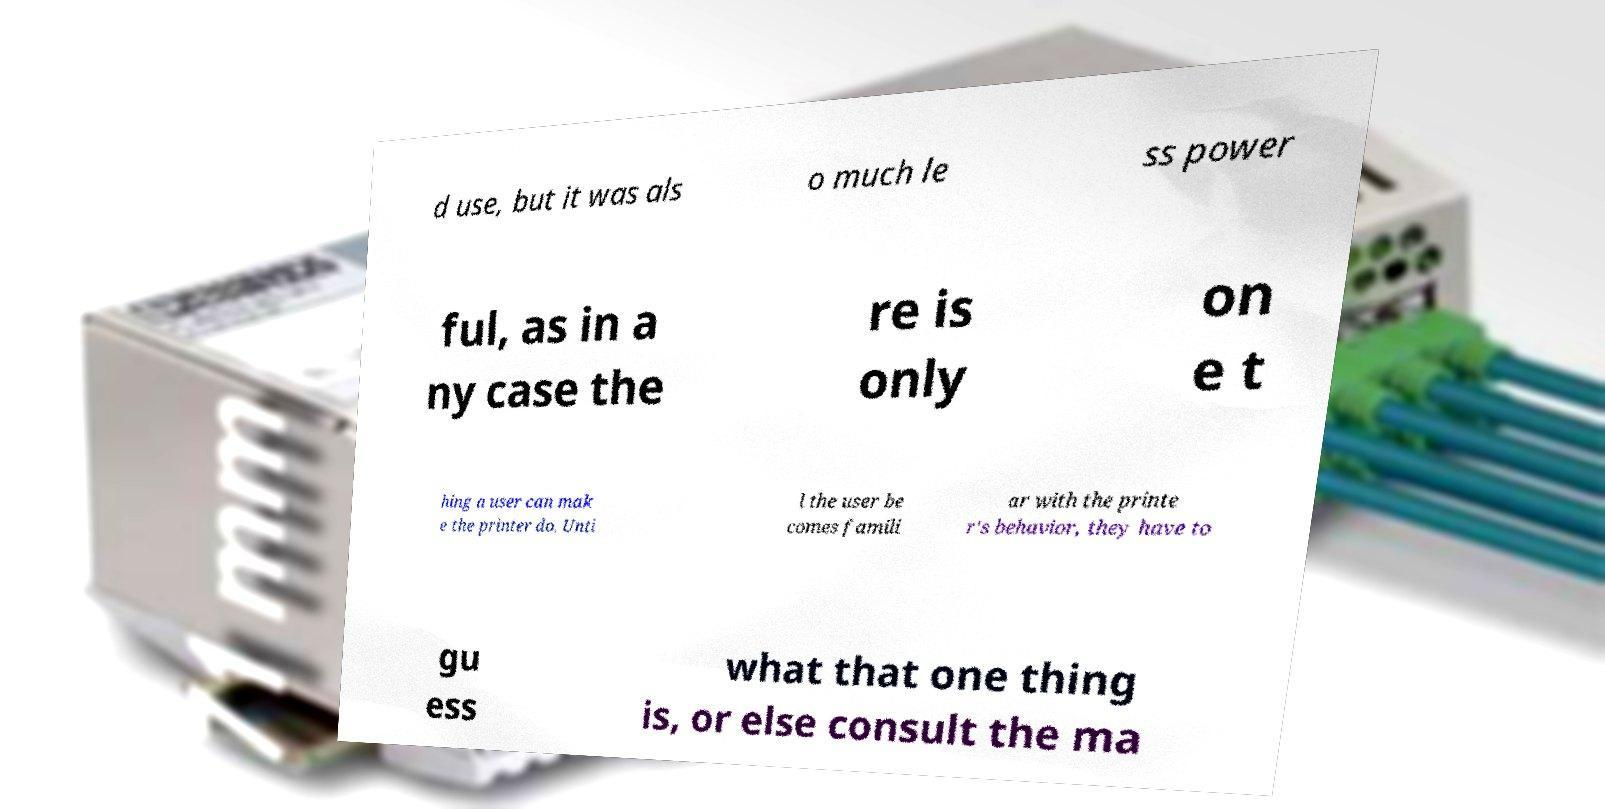Please identify and transcribe the text found in this image. d use, but it was als o much le ss power ful, as in a ny case the re is only on e t hing a user can mak e the printer do. Unti l the user be comes famili ar with the printe r's behavior, they have to gu ess what that one thing is, or else consult the ma 